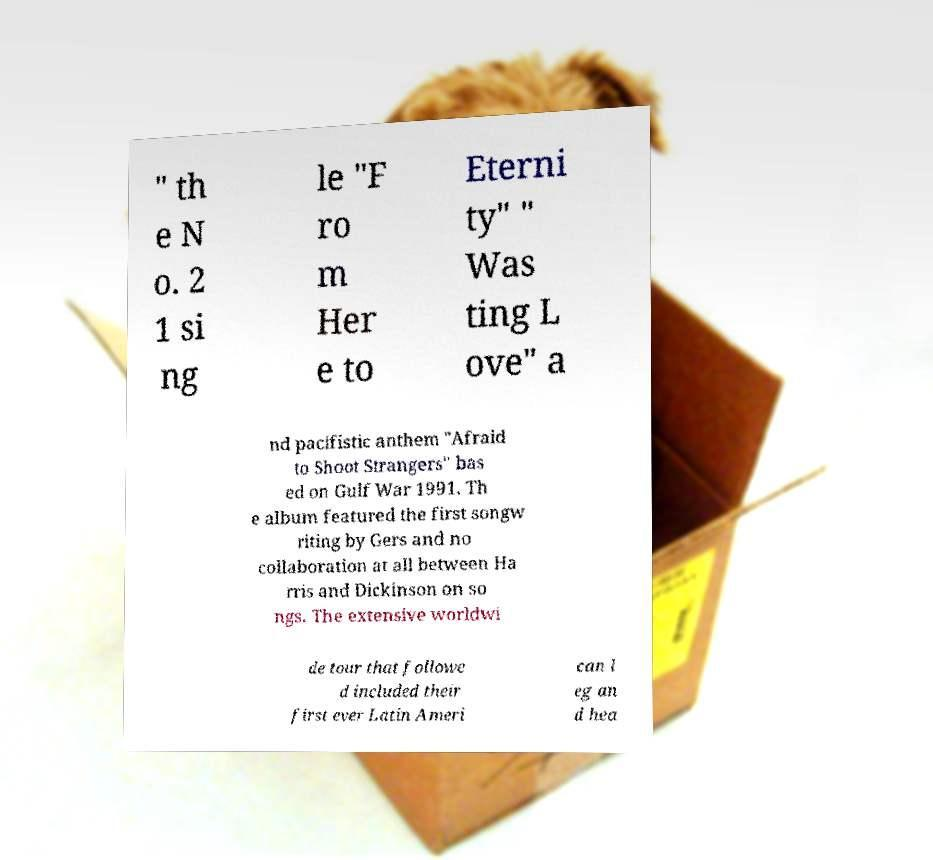Can you read and provide the text displayed in the image?This photo seems to have some interesting text. Can you extract and type it out for me? " th e N o. 2 1 si ng le "F ro m Her e to Eterni ty" " Was ting L ove" a nd pacifistic anthem "Afraid to Shoot Strangers" bas ed on Gulf War 1991. Th e album featured the first songw riting by Gers and no collaboration at all between Ha rris and Dickinson on so ngs. The extensive worldwi de tour that followe d included their first ever Latin Ameri can l eg an d hea 